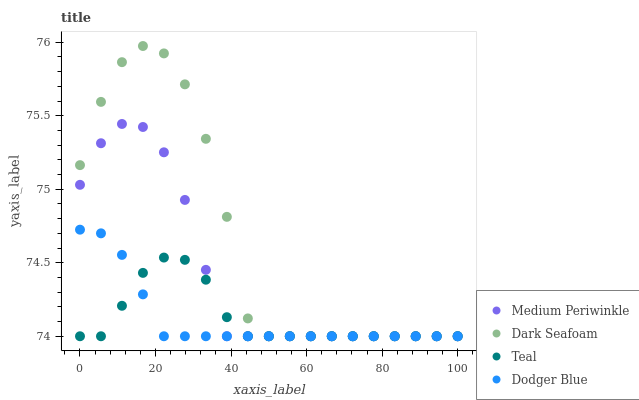Does Dodger Blue have the minimum area under the curve?
Answer yes or no. Yes. Does Dark Seafoam have the maximum area under the curve?
Answer yes or no. Yes. Does Medium Periwinkle have the minimum area under the curve?
Answer yes or no. No. Does Medium Periwinkle have the maximum area under the curve?
Answer yes or no. No. Is Dodger Blue the smoothest?
Answer yes or no. Yes. Is Dark Seafoam the roughest?
Answer yes or no. Yes. Is Medium Periwinkle the smoothest?
Answer yes or no. No. Is Medium Periwinkle the roughest?
Answer yes or no. No. Does Dodger Blue have the lowest value?
Answer yes or no. Yes. Does Dark Seafoam have the highest value?
Answer yes or no. Yes. Does Medium Periwinkle have the highest value?
Answer yes or no. No. Does Dark Seafoam intersect Dodger Blue?
Answer yes or no. Yes. Is Dark Seafoam less than Dodger Blue?
Answer yes or no. No. Is Dark Seafoam greater than Dodger Blue?
Answer yes or no. No. 